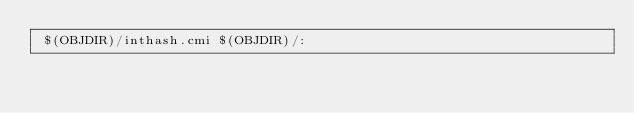<code> <loc_0><loc_0><loc_500><loc_500><_D_> $(OBJDIR)/inthash.cmi $(OBJDIR)/:
</code> 